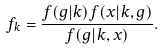<formula> <loc_0><loc_0><loc_500><loc_500>f _ { k } = \frac { f ( g | k ) f ( x | k , g ) } { f ( g | k , x ) } .</formula> 